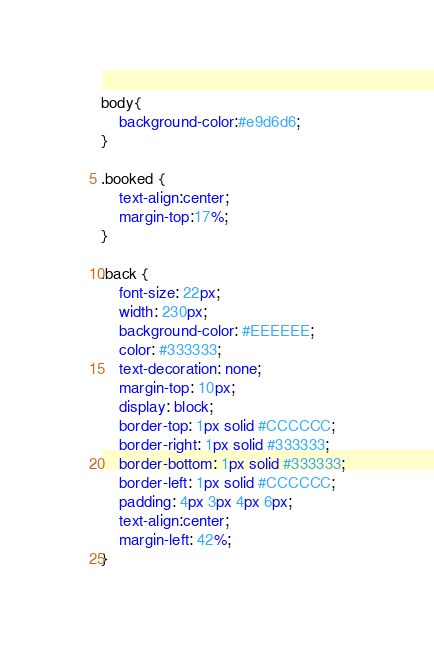<code> <loc_0><loc_0><loc_500><loc_500><_CSS_>body{
	background-color:#e9d6d6;
}

.booked {
	text-align:center;
	margin-top:17%;
}

.back {
	font-size: 22px;
    width: 230px;
	background-color: #EEEEEE;
	color: #333333;
	text-decoration: none;
    margin-top: 10px;
    display: block;
    border-top: 1px solid #CCCCCC;
    border-right: 1px solid #333333;
    border-bottom: 1px solid #333333;
    border-left: 1px solid #CCCCCC;
    padding: 4px 3px 4px 6px;
	text-align:center;
	margin-left: 42%;
}</code> 